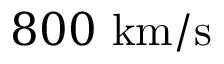Convert formula to latex. <formula><loc_0><loc_0><loc_500><loc_500>8 0 0 k m / s</formula> 